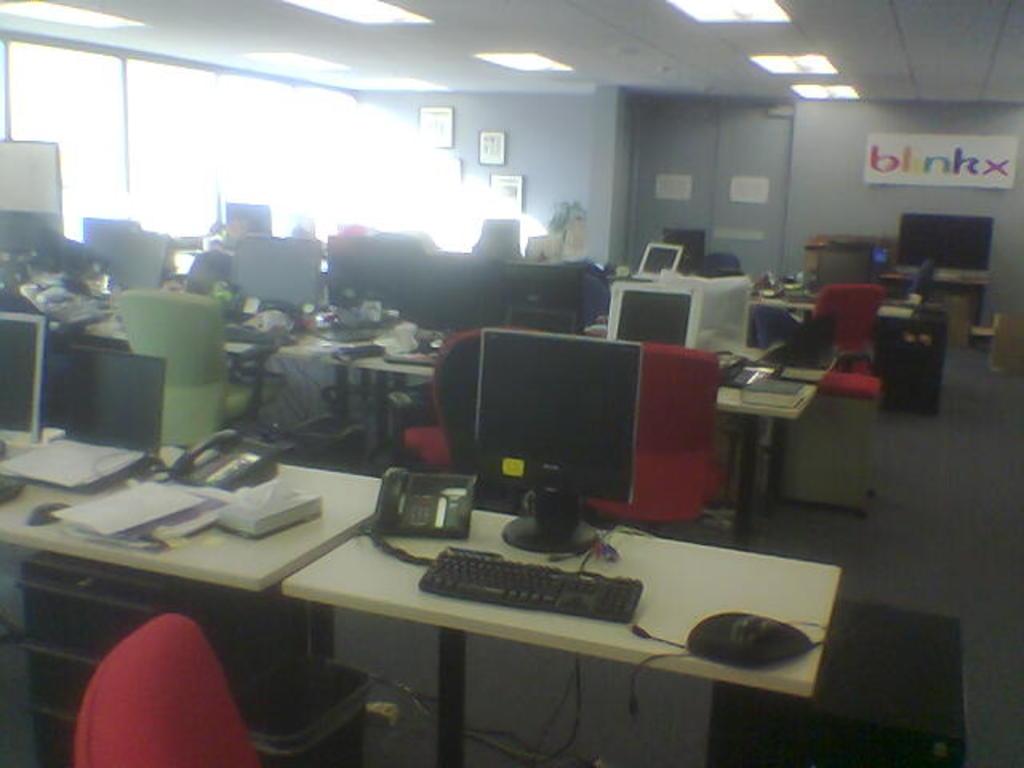What corporation does this office belong to?
Give a very brief answer. Blinkx. 